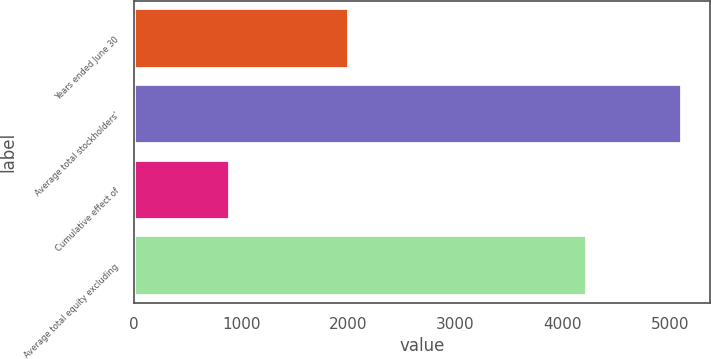Convert chart to OTSL. <chart><loc_0><loc_0><loc_500><loc_500><bar_chart><fcel>Years ended June 30<fcel>Average total stockholders'<fcel>Cumulative effect of<fcel>Average total equity excluding<nl><fcel>2008<fcel>5117.5<fcel>894.7<fcel>4222.8<nl></chart> 